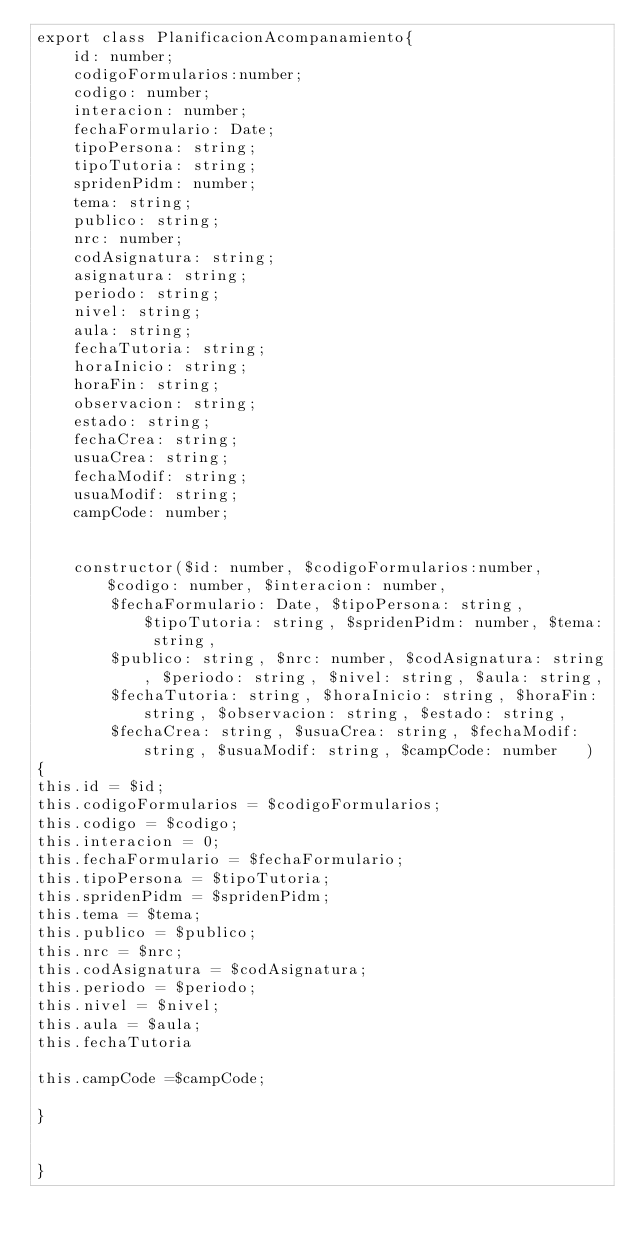Convert code to text. <code><loc_0><loc_0><loc_500><loc_500><_TypeScript_>export class PlanificacionAcompanamiento{
    id: number;
    codigoFormularios:number;
    codigo: number;
    interacion: number;
    fechaFormulario: Date;
    tipoPersona: string;
    tipoTutoria: string;
    spridenPidm: number;
    tema: string;
    publico: string;
    nrc: number;
    codAsignatura: string;
    asignatura: string;
    periodo: string;
    nivel: string;
    aula: string;
    fechaTutoria: string;
    horaInicio: string;
    horaFin: string;
    observacion: string;
    estado: string;
    fechaCrea: string;
    usuaCrea: string;
    fechaModif: string;
    usuaModif: string;
    campCode: number;


    constructor($id: number, $codigoFormularios:number, $codigo: number, $interacion: number,
        $fechaFormulario: Date, $tipoPersona: string, $tipoTutoria: string, $spridenPidm: number, $tema: string,
        $publico: string, $nrc: number, $codAsignatura: string, $periodo: string, $nivel: string, $aula: string, 
        $fechaTutoria: string, $horaInicio: string, $horaFin: string, $observacion: string, $estado: string, 
        $fechaCrea: string, $usuaCrea: string, $fechaModif: string, $usuaModif: string, $campCode: number   )
{
this.id = $id;
this.codigoFormularios = $codigoFormularios;
this.codigo = $codigo;
this.interacion = 0;
this.fechaFormulario = $fechaFormulario;
this.tipoPersona = $tipoTutoria;
this.spridenPidm = $spridenPidm;
this.tema = $tema;
this.publico = $publico;
this.nrc = $nrc;
this.codAsignatura = $codAsignatura;
this.periodo = $periodo;
this.nivel = $nivel;
this.aula = $aula;
this.fechaTutoria

this.campCode =$campCode;

}


}</code> 